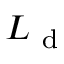Convert formula to latex. <formula><loc_0><loc_0><loc_500><loc_500>L _ { d }</formula> 